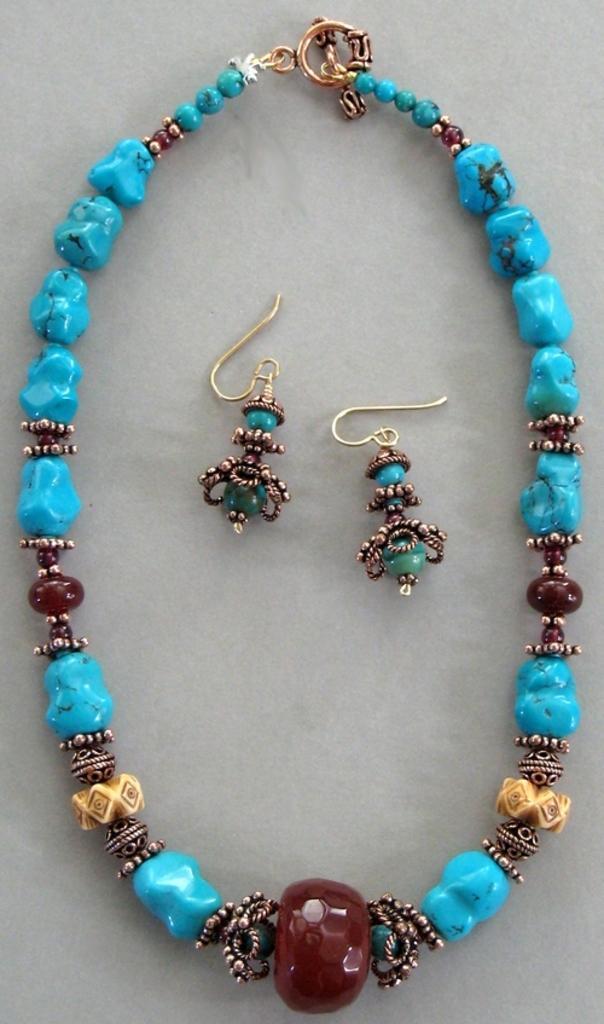In one or two sentences, can you explain what this image depicts? There is a necklace with blue and maroon stones. Also there are earrings. 